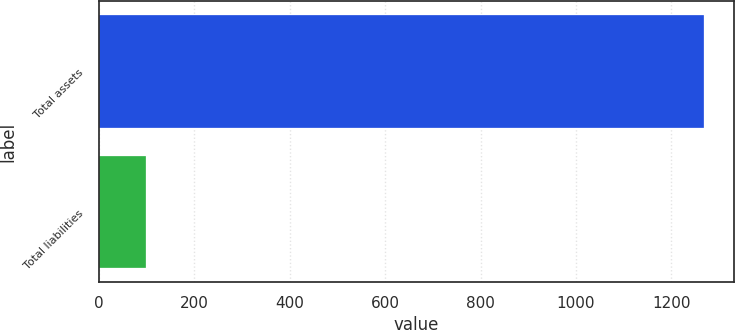<chart> <loc_0><loc_0><loc_500><loc_500><bar_chart><fcel>Total assets<fcel>Total liabilities<nl><fcel>1268<fcel>100<nl></chart> 